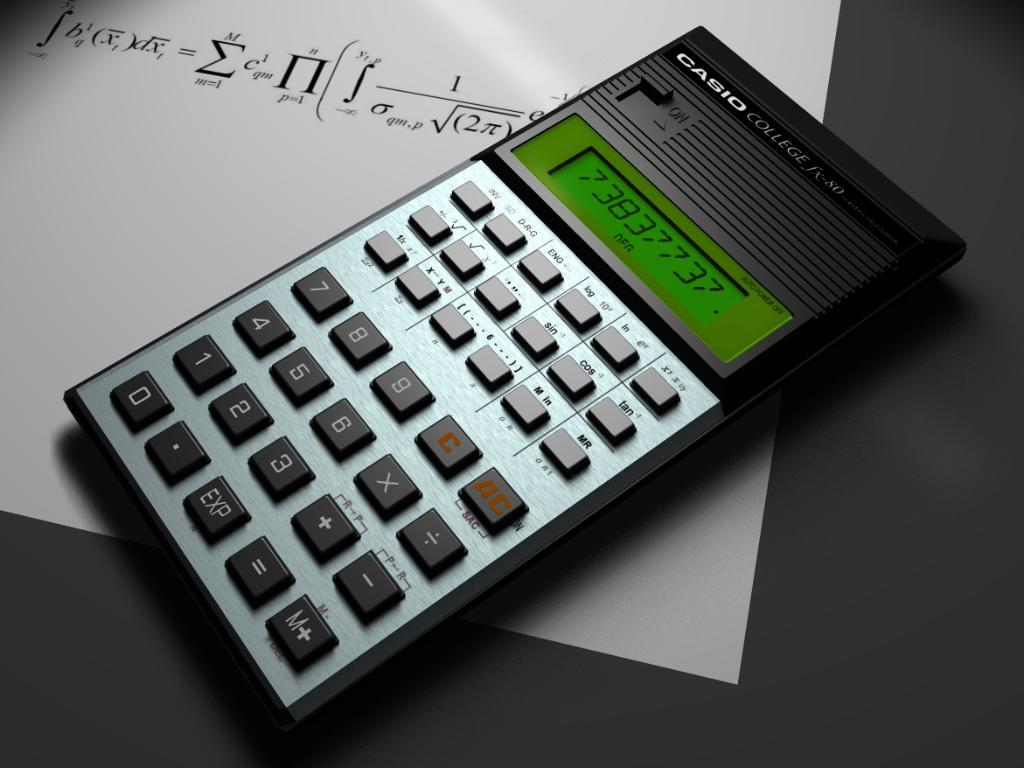<image>
Share a concise interpretation of the image provided. the number 0 is on the calculator with a gray background 